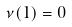Convert formula to latex. <formula><loc_0><loc_0><loc_500><loc_500>\nu ( 1 ) = 0</formula> 